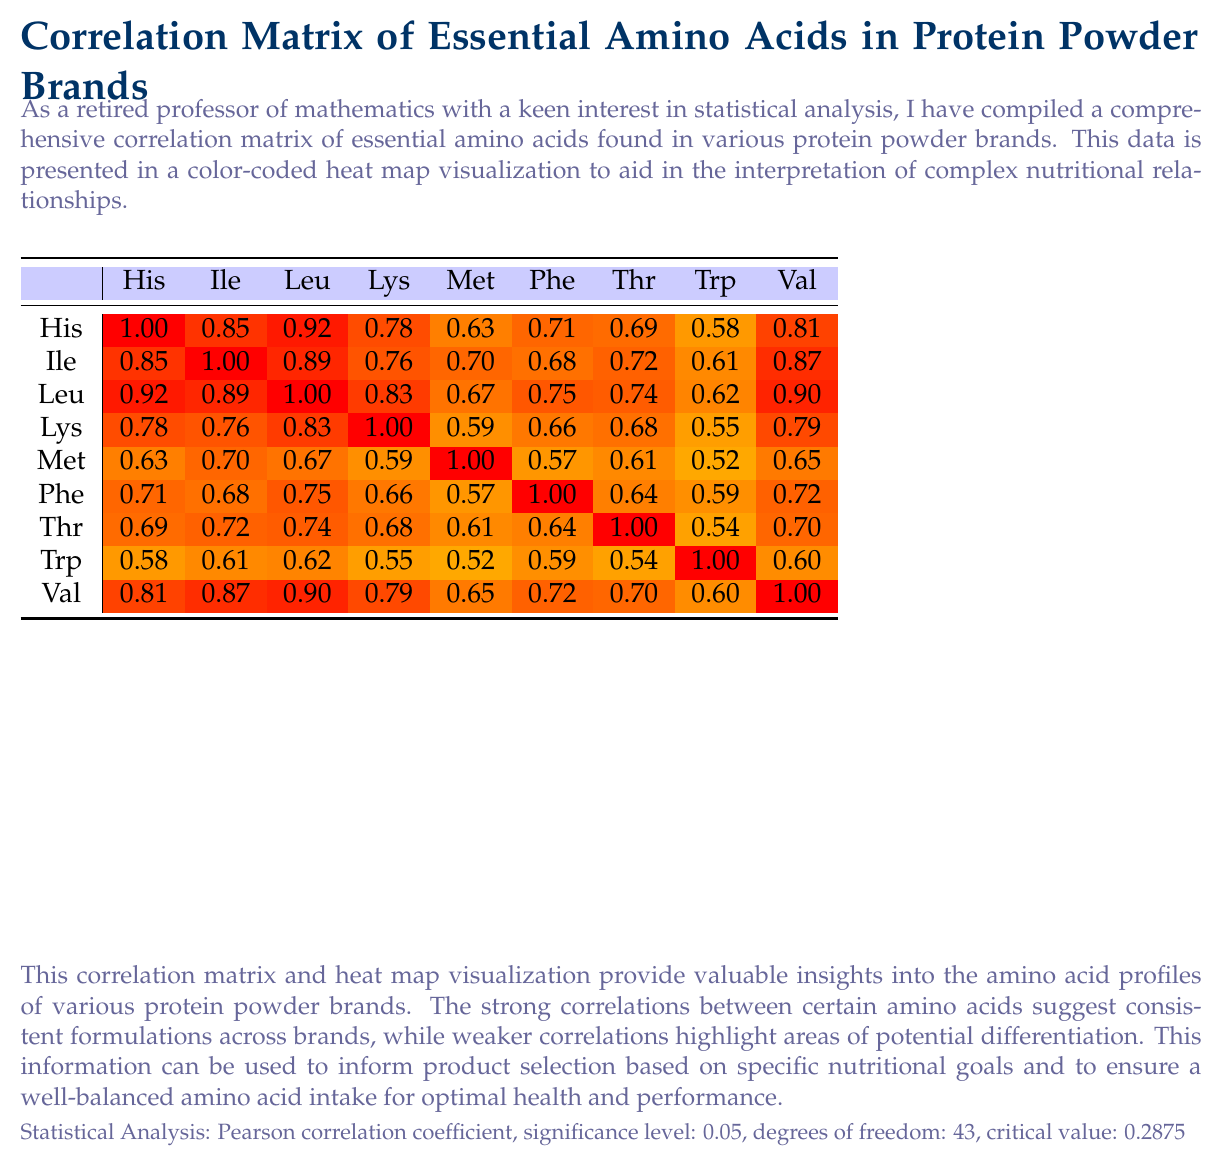what is the overall trend in the correlation between different essential amino acids in the various protein powder brands? The correlation matrix shows most values close to 1, indicating highly positive correlations among the essential amino acids.
Answer: Strong positive correlations which amino acids have the strongest positive correlation? A. Histidine and Isoleucine B. Leucine and Isoleucine C. Tryptophan and Methionine The correlation between Leucine and Isoleucine is 0.89, which is very high and indicates a strong positive correlation.
Answer: B how does methionine correlate with lysine? The correlation value between Methionine and Lysine is 0.59, indicating a moderate positive correlation.
Answer: 0.59 what are the colors representing the strongest and weakest correlations in the heat map? The strongest correlations (close to 1) are represented by red, while the weakest (around 0.52) are represented by dark orange shades.
Answer: Red and dark orange what is the title of this document? The title is prominently located at the top of the document.
Answer: Correlation Matrix of Essential Amino Acids in Protein Powder Brands is there a color representing negative correlations in the heat map? All correlations are positive, as indicated by the color gradients ranging from red to orange without negative values.
Answer: No summarize the main idea of the document. This document gives a visual and numerical correlation matrix for essential amino acids across different protein powder brands, highlighting both strong and weak correlations to aid in nutritional analysis and product selection.
Answer: The document presents a correlation matrix of essential amino acids in various protein powder brands using a color-coded heat map to visualize the relationships. It provides insights into the amino acid profiles and the consistency of formulations. which pair of amino acids has the lowest correlation? A. Histidine and Isoleucine B. Leucine and Isoleucine C. Tryptophan and Methionine D. Lysine and Threonine Tryptophan and Methionine have the lowest correlation of 0.52.
Answer: C what is the significance level used for the statistical analysis? The document states that the statistical analysis used a significance level of 0.05.
Answer: 0.05 how does phenylalanine correlate with leucine? The correlation value between Phenylalanine and Leucine is 0.75, indicating a strong positive correlation.
Answer: 0.75 why is the information about amino acid correlations important for choosing a protein powder? Understanding the relationship between amino acids can guide consumers toward products that meet specific nutritional goals and offer a balanced profile.
Answer: It helps ensure a well-balanced amino acid intake and identify consistent formulations across brands. what is the method used for calculating the correlations? The document specifies that the Pearson correlation coefficient was used for the analysis.
Answer: Pearson correlation coefficient how would you interpret a correlation value of 0.87 between Valine and Isoleucine? A correlation value of 0.87 indicates a strong positive relationship, suggesting these amino acids are often found in similar proportions across the protein powders analyzed.
Answer: Strong positive correlation which protein powder brands are analyzed in this document? The document lists these five brands as the subjects of analysis.
Answer: Optimum Nutrition Gold Standard, MyProtein Impact Whey, Dymatize ISO100, BSN Syntha-6, Garden of Life Raw Organic which statement is true regarding the correlation between Lysine and Threonine? A. It is weak and negative. B. It is moderate and positive. C. It is moderately strong and positive. D. It is the strongest correlation in the matrix. The correlation between Lysine and Threonine is 0.68, indicating a moderately strong and positive relationship.
Answer: C is the amino acid tryptophan independent of all other amino acids? The correlation values show that Tryptophan has positive correlations with all other amino acids, indicating it is not independent.
Answer: No 